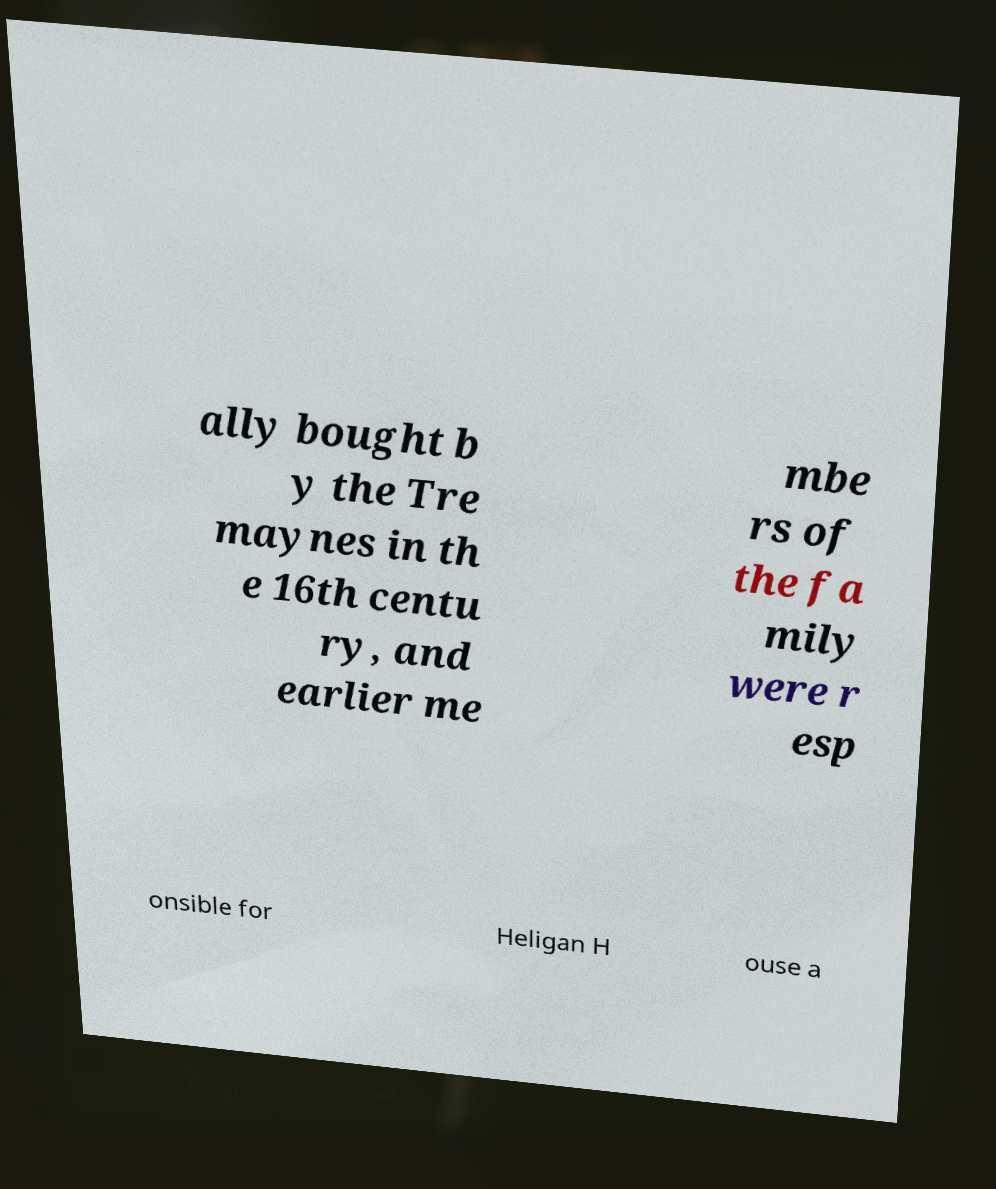What messages or text are displayed in this image? I need them in a readable, typed format. ally bought b y the Tre maynes in th e 16th centu ry, and earlier me mbe rs of the fa mily were r esp onsible for Heligan H ouse a 